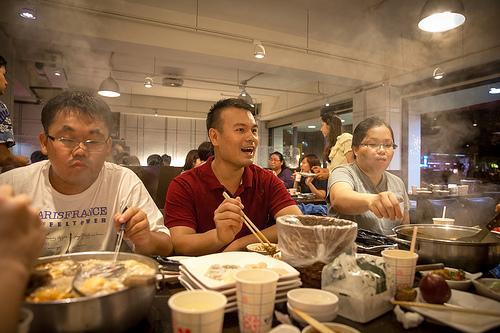Focus on describing the clothing and appearance of one person in the image. A man is wearing a red collared polo shirt, eyeglasses, and has a semi-open mouth, possibly speaking to someone during a meal. Mention an action being performed by one person in the image. A man is holding a pair of chopsticks in his right hand, likely to pick up food during the meal. Describe an interaction between two people in the image. A woman is sipping a drink from a plastic cup while sitting next to a man who is holding chopsticks during a meal. Choose any object on the table and describe its location in relation to another object. A white plate is present on the table, placed close to a red apple, both appearing to be a part of the meal being shared by the individuals. List five objects or people found in the image. A red apple, a stack of small white bowls, chopsticks, a man wearing a red shirt, and a woman wearing glasses are in the image. Describe a unique feature or design of an item in the image. There is a paper cup on the table which has blue perpendicular lines and flowers printed on its surface. Mention three food items and two utensils on the table. There is a red apple, a bowl of soup, and a stack of white plates on the table, along with a pair of chopsticks and a metal serving spoon. Describe the lighting conditions in the image. The room has overhead lighting attached to the ceiling, and a large window indicates it is evening outdoors, creating a warm ambiance. Describe the general atmosphere and event happening in the image. The image shows a casual dining scene, where three people are seated together enjoying a meal with various dishes and utensils on the table. Provide a brief overview of the scene in the image. People are sitting at a table having a meal, with a man holding chopsticks, a woman wearing glasses, and various dishes and utensils around them. 